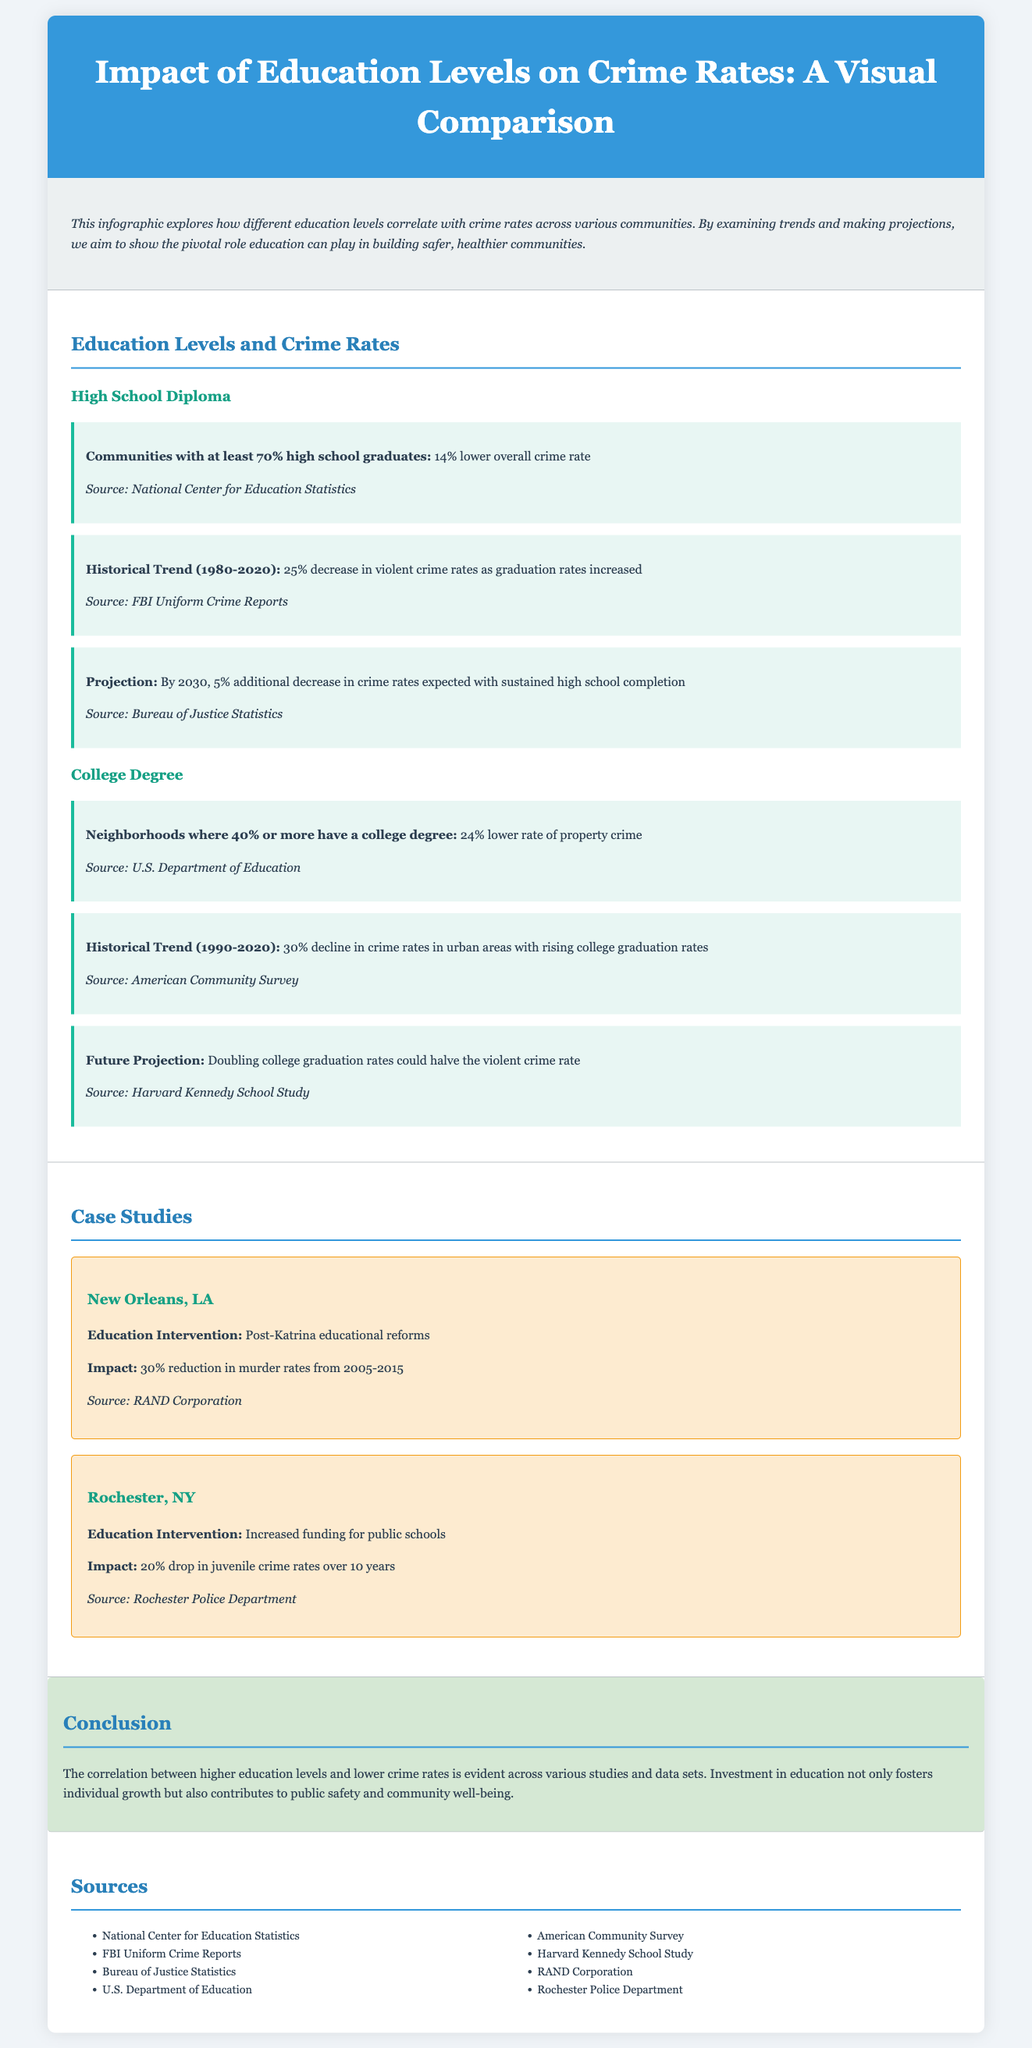What is the percentage decrease in overall crime rate for communities with at least 70% high school graduates? The document states that communities with at least 70% high school graduates experience a 14% lower overall crime rate.
Answer: 14% What was the decline in violent crime rates as graduation rates increased from 1980 to 2020? The historical trend indicates a 25% decrease in violent crime rates as graduation rates increased during this period.
Answer: 25% By what percentage is the crime rate expected to decrease by 2030 with sustained high school completion? The projection indicates an expected additional decrease of 5% in crime rates by 2030 with sustained high school completion.
Answer: 5% What is the percentage decrease in property crime for neighborhoods where 40% or more have a college degree? The document mentions a 24% lower rate of property crime in neighborhoods where 40% or more have a college degree.
Answer: 24% What historical trend occurred from 1990 to 2020 in urban areas with rising college graduation rates? There was a 30% decline in crime rates in urban areas with rising college graduation rates during this period.
Answer: 30% What is the projected impact on violent crime rates if college graduation rates double? The document states that doubling college graduation rates could halve the violent crime rate.
Answer: halve What was the impact of educational reforms in New Orleans from 2005 to 2015? The educational reforms in New Orleans led to a 30% reduction in murder rates from 2005 to 2015.
Answer: 30% How much did juvenile crime rates drop in Rochester, NY, over 10 years due to increased funding for public schools? The funding increase for public schools in Rochester resulted in a 20% drop in juvenile crime rates over 10 years.
Answer: 20% What overarching theme does the conclusion suggest regarding education and crime rates? The conclusion emphasizes that higher education levels correlate with lower crime rates, highlighting education's role in public safety and community well-being.
Answer: correlation 